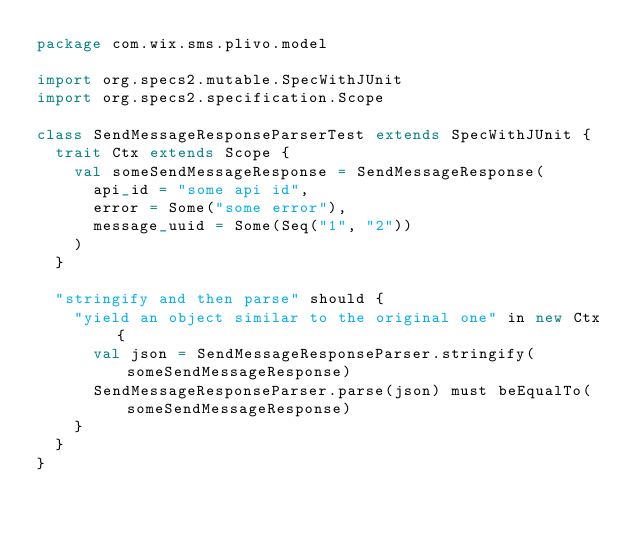<code> <loc_0><loc_0><loc_500><loc_500><_Scala_>package com.wix.sms.plivo.model

import org.specs2.mutable.SpecWithJUnit
import org.specs2.specification.Scope

class SendMessageResponseParserTest extends SpecWithJUnit {
  trait Ctx extends Scope {
    val someSendMessageResponse = SendMessageResponse(
      api_id = "some api id",
      error = Some("some error"),
      message_uuid = Some(Seq("1", "2"))
    )
  }

  "stringify and then parse" should {
    "yield an object similar to the original one" in new Ctx {
      val json = SendMessageResponseParser.stringify(someSendMessageResponse)
      SendMessageResponseParser.parse(json) must beEqualTo(someSendMessageResponse)
    }
  }
}
</code> 